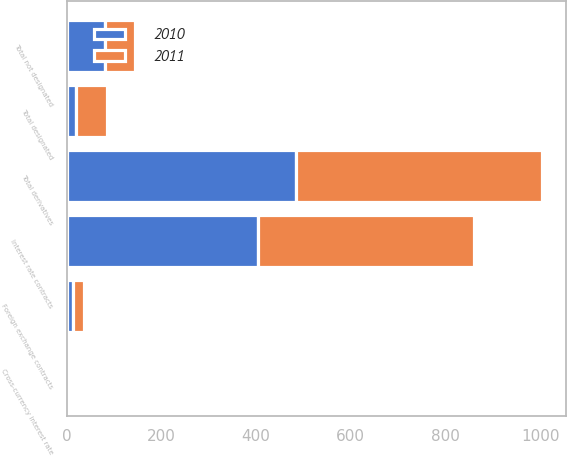Convert chart. <chart><loc_0><loc_0><loc_500><loc_500><stacked_bar_chart><ecel><fcel>Interest rate contracts<fcel>Foreign exchange contracts<fcel>Cross-currency interest rate<fcel>Total not designated<fcel>Total derivatives<fcel>Total designated<nl><fcel>2010<fcel>404<fcel>12<fcel>2<fcel>81<fcel>485<fcel>20<nl><fcel>2011<fcel>457<fcel>24<fcel>3<fcel>63<fcel>520<fcel>65<nl></chart> 